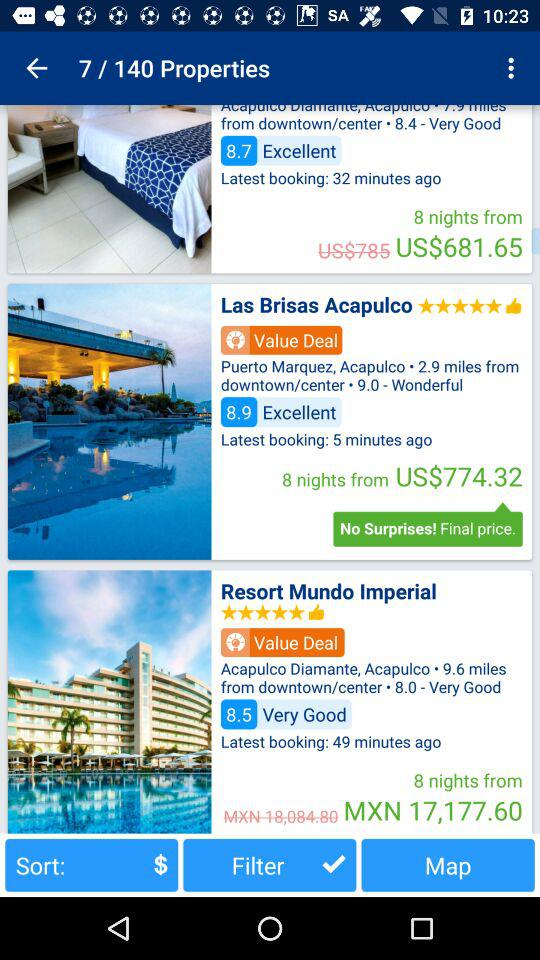What is the rating for "Resort Mundo Imperial"? The rating for "Resort Mundo Imperial" is 5 stars. 